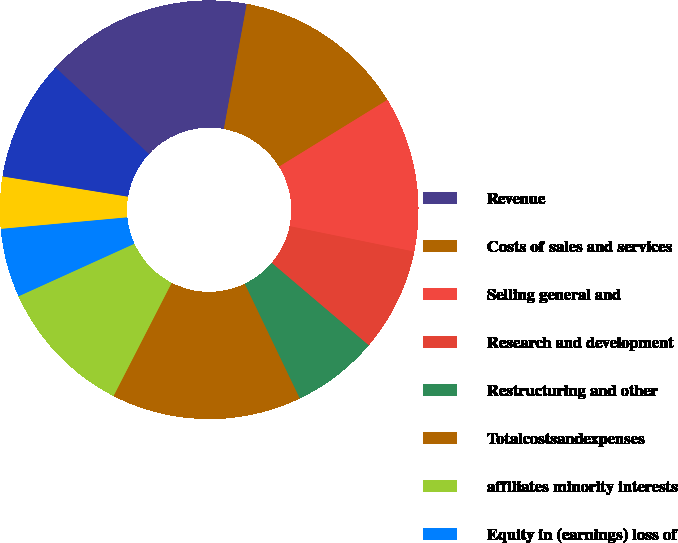<chart> <loc_0><loc_0><loc_500><loc_500><pie_chart><fcel>Revenue<fcel>Costs of sales and services<fcel>Selling general and<fcel>Research and development<fcel>Restructuring and other<fcel>Totalcostsandexpenses<fcel>affiliates minority interests<fcel>Equity in (earnings) loss of<fcel>Minority interests<fcel>Netincome(loss)<nl><fcel>16.0%<fcel>13.33%<fcel>12.0%<fcel>8.0%<fcel>6.67%<fcel>14.67%<fcel>10.67%<fcel>5.33%<fcel>4.0%<fcel>9.33%<nl></chart> 